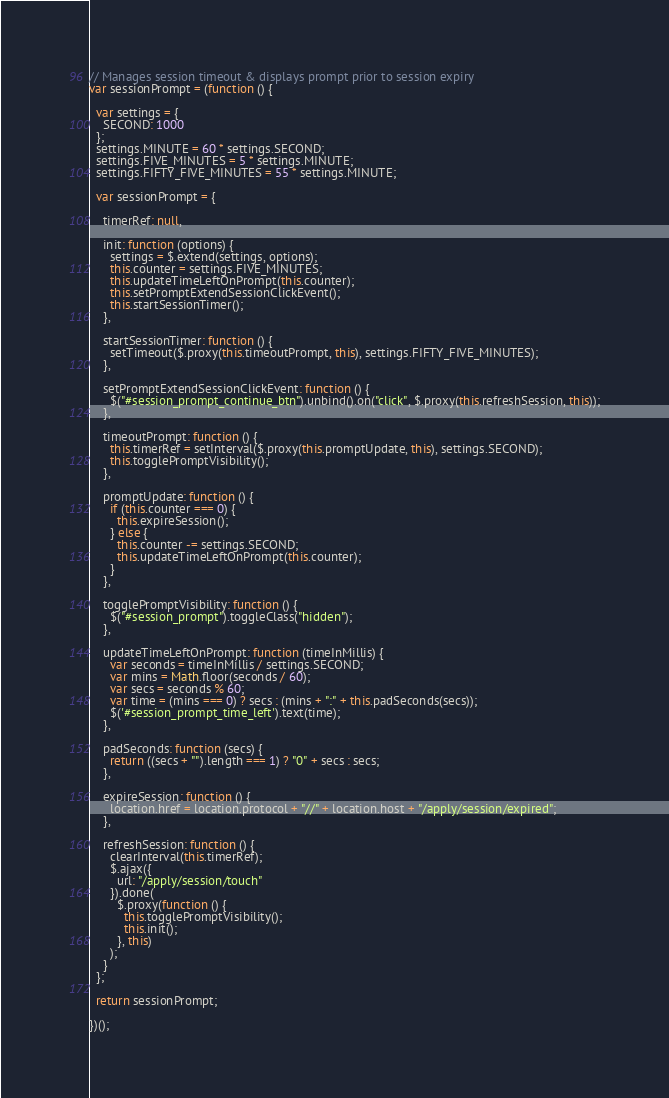<code> <loc_0><loc_0><loc_500><loc_500><_JavaScript_>// Manages session timeout & displays prompt prior to session expiry
var sessionPrompt = (function () {

  var settings = {
    SECOND: 1000
  };
  settings.MINUTE = 60 * settings.SECOND;
  settings.FIVE_MINUTES = 5 * settings.MINUTE;
  settings.FIFTY_FIVE_MINUTES = 55 * settings.MINUTE;

  var sessionPrompt = {

    timerRef: null,

    init: function (options) {
      settings = $.extend(settings, options);
      this.counter = settings.FIVE_MINUTES;
      this.updateTimeLeftOnPrompt(this.counter);
      this.setPromptExtendSessionClickEvent();
      this.startSessionTimer();
    },

    startSessionTimer: function () {
      setTimeout($.proxy(this.timeoutPrompt, this), settings.FIFTY_FIVE_MINUTES);
    },

    setPromptExtendSessionClickEvent: function () {
      $("#session_prompt_continue_btn").unbind().on("click", $.proxy(this.refreshSession, this));
    },

    timeoutPrompt: function () {
      this.timerRef = setInterval($.proxy(this.promptUpdate, this), settings.SECOND);
      this.togglePromptVisibility();
    },

    promptUpdate: function () {
      if (this.counter === 0) {
        this.expireSession();
      } else {
        this.counter -= settings.SECOND;
        this.updateTimeLeftOnPrompt(this.counter);
      }
    },

    togglePromptVisibility: function () {
      $("#session_prompt").toggleClass("hidden");
    },

    updateTimeLeftOnPrompt: function (timeInMillis) {
      var seconds = timeInMillis / settings.SECOND;
      var mins = Math.floor(seconds / 60);
      var secs = seconds % 60;
      var time = (mins === 0) ? secs : (mins + ":" + this.padSeconds(secs));
      $('#session_prompt_time_left').text(time);
    },

    padSeconds: function (secs) {
      return ((secs + "").length === 1) ? "0" + secs : secs;
    },

    expireSession: function () {
      location.href = location.protocol + "//" + location.host + "/apply/session/expired";
    },

    refreshSession: function () {
      clearInterval(this.timerRef);
      $.ajax({
        url: "/apply/session/touch"
      }).done(
        $.proxy(function () {
          this.togglePromptVisibility();
          this.init();
        }, this)
      );
    }
  };

  return sessionPrompt;

})();
</code> 